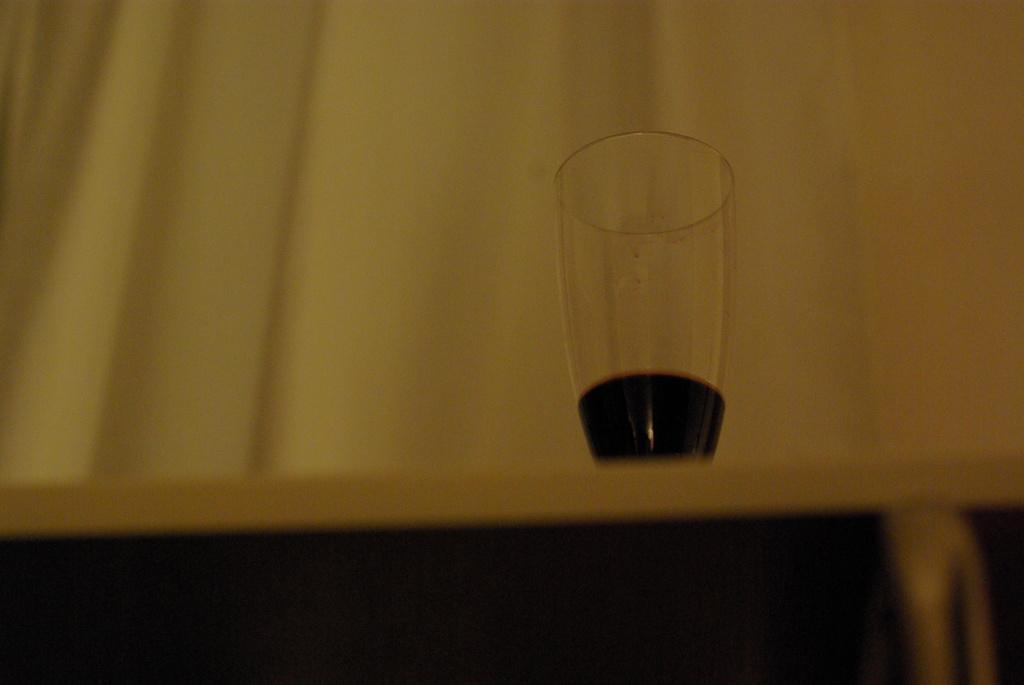Please provide a concise description of this image. There is a room. There is a table. and there is a wine glass on a table. We can see in background yellow color curtain. 